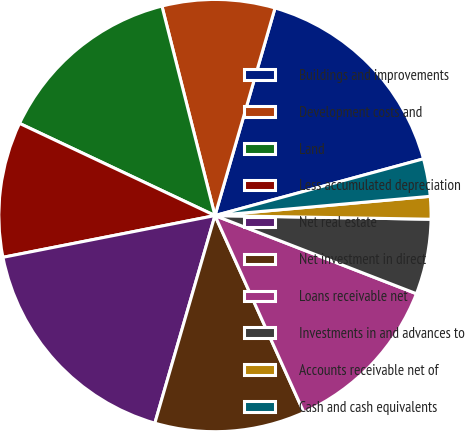Convert chart. <chart><loc_0><loc_0><loc_500><loc_500><pie_chart><fcel>Buildings and improvements<fcel>Development costs and<fcel>Land<fcel>Less accumulated depreciation<fcel>Net real estate<fcel>Net investment in direct<fcel>Loans receivable net<fcel>Investments in and advances to<fcel>Accounts receivable net of<fcel>Cash and cash equivalents<nl><fcel>16.29%<fcel>8.43%<fcel>14.04%<fcel>10.11%<fcel>17.42%<fcel>11.24%<fcel>12.36%<fcel>5.62%<fcel>1.69%<fcel>2.81%<nl></chart> 